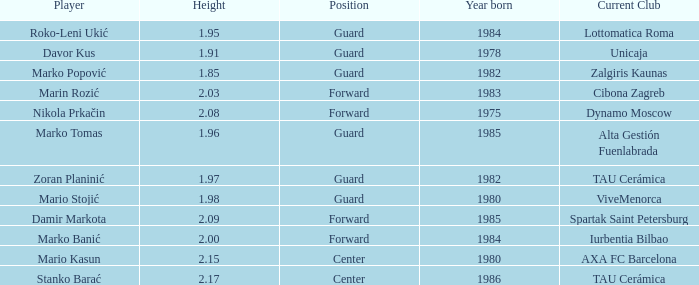In which position does mario kasun participate? Center. 